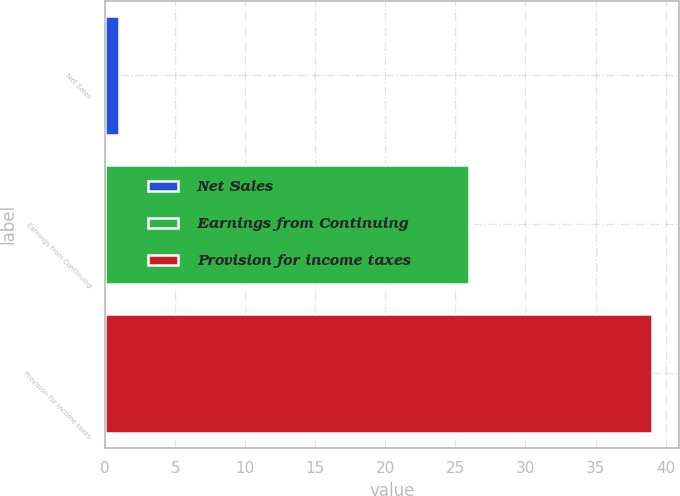Convert chart. <chart><loc_0><loc_0><loc_500><loc_500><bar_chart><fcel>Net Sales<fcel>Earnings from Continuing<fcel>Provision for income taxes<nl><fcel>1<fcel>26<fcel>39<nl></chart> 